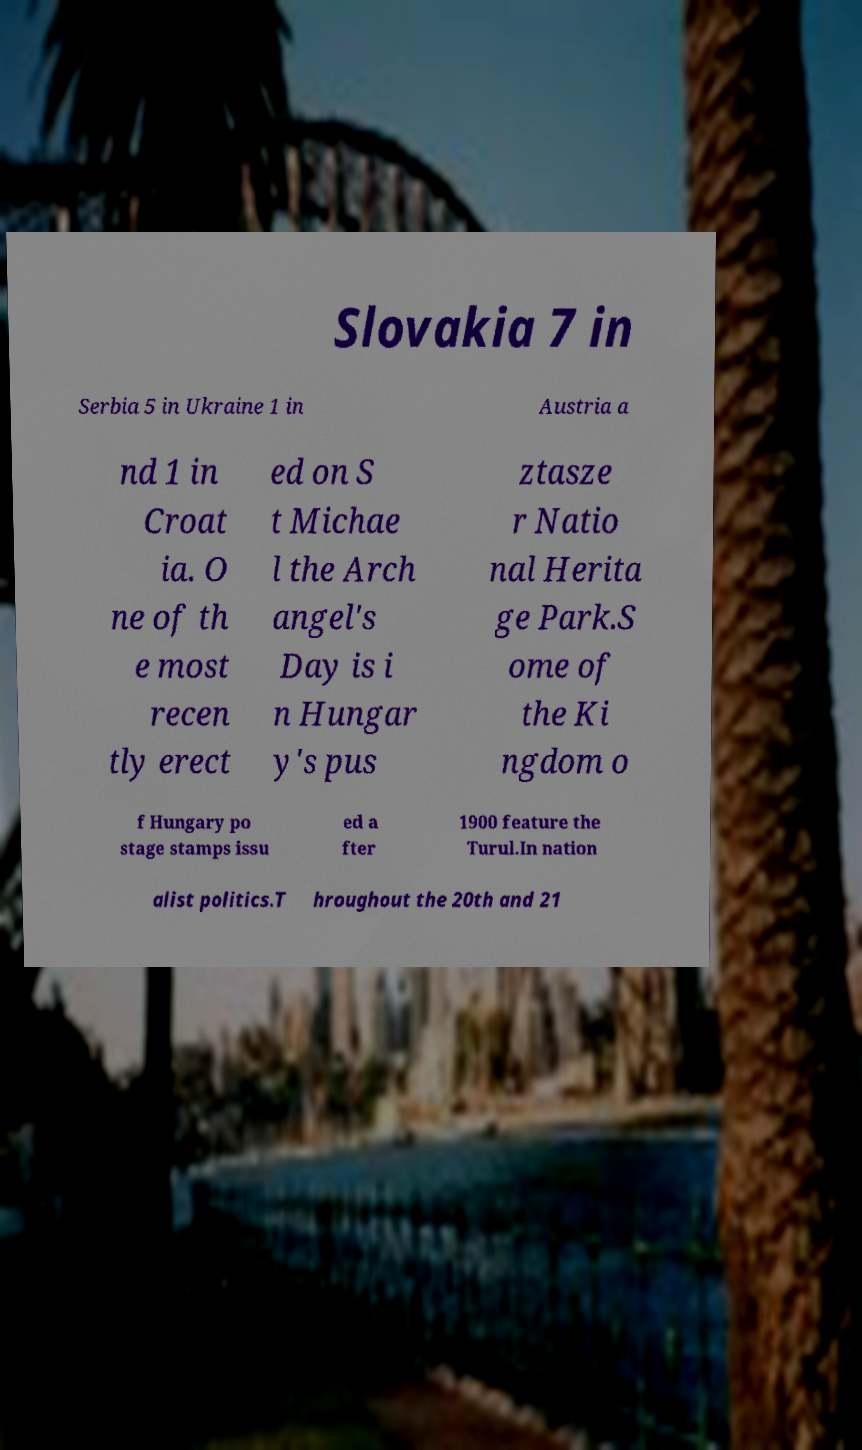I need the written content from this picture converted into text. Can you do that? Slovakia 7 in Serbia 5 in Ukraine 1 in Austria a nd 1 in Croat ia. O ne of th e most recen tly erect ed on S t Michae l the Arch angel's Day is i n Hungar y's pus ztasze r Natio nal Herita ge Park.S ome of the Ki ngdom o f Hungary po stage stamps issu ed a fter 1900 feature the Turul.In nation alist politics.T hroughout the 20th and 21 